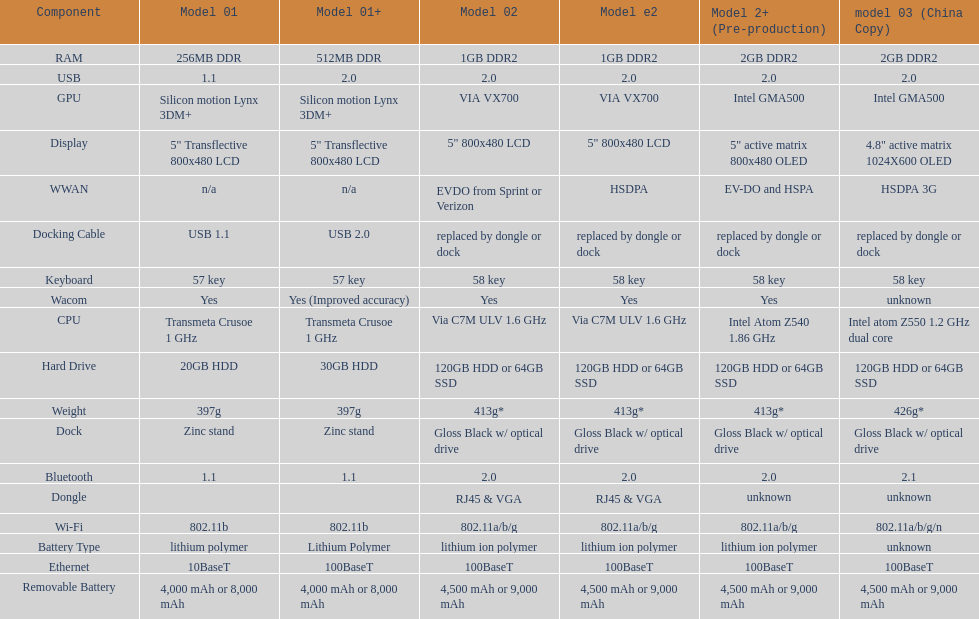Write the full table. {'header': ['Component', 'Model 01', 'Model 01+', 'Model 02', 'Model e2', 'Model 2+ (Pre-production)', 'model 03 (China Copy)'], 'rows': [['RAM', '256MB DDR', '512MB DDR', '1GB DDR2', '1GB DDR2', '2GB DDR2', '2GB DDR2'], ['USB', '1.1', '2.0', '2.0', '2.0', '2.0', '2.0'], ['GPU', 'Silicon motion Lynx 3DM+', 'Silicon motion Lynx 3DM+', 'VIA VX700', 'VIA VX700', 'Intel GMA500', 'Intel GMA500'], ['Display', '5" Transflective 800x480 LCD', '5" Transflective 800x480 LCD', '5" 800x480 LCD', '5" 800x480 LCD', '5" active matrix 800x480 OLED', '4.8" active matrix 1024X600 OLED'], ['WWAN', 'n/a', 'n/a', 'EVDO from Sprint or Verizon', 'HSDPA', 'EV-DO and HSPA', 'HSDPA 3G'], ['Docking Cable', 'USB 1.1', 'USB 2.0', 'replaced by dongle or dock', 'replaced by dongle or dock', 'replaced by dongle or dock', 'replaced by dongle or dock'], ['Keyboard', '57 key', '57 key', '58 key', '58 key', '58 key', '58 key'], ['Wacom', 'Yes', 'Yes (Improved accuracy)', 'Yes', 'Yes', 'Yes', 'unknown'], ['CPU', 'Transmeta Crusoe 1\xa0GHz', 'Transmeta Crusoe 1\xa0GHz', 'Via C7M ULV 1.6\xa0GHz', 'Via C7M ULV 1.6\xa0GHz', 'Intel Atom Z540 1.86\xa0GHz', 'Intel atom Z550 1.2\xa0GHz dual core'], ['Hard Drive', '20GB HDD', '30GB HDD', '120GB HDD or 64GB SSD', '120GB HDD or 64GB SSD', '120GB HDD or 64GB SSD', '120GB HDD or 64GB SSD'], ['Weight', '397g', '397g', '413g*', '413g*', '413g*', '426g*'], ['Dock', 'Zinc stand', 'Zinc stand', 'Gloss Black w/ optical drive', 'Gloss Black w/ optical drive', 'Gloss Black w/ optical drive', 'Gloss Black w/ optical drive'], ['Bluetooth', '1.1', '1.1', '2.0', '2.0', '2.0', '2.1'], ['Dongle', '', '', 'RJ45 & VGA', 'RJ45 & VGA', 'unknown', 'unknown'], ['Wi-Fi', '802.11b', '802.11b', '802.11a/b/g', '802.11a/b/g', '802.11a/b/g', '802.11a/b/g/n'], ['Battery Type', 'lithium polymer', 'Lithium Polymer', 'lithium ion polymer', 'lithium ion polymer', 'lithium ion polymer', 'unknown'], ['Ethernet', '10BaseT', '100BaseT', '100BaseT', '100BaseT', '100BaseT', '100BaseT'], ['Removable Battery', '4,000 mAh or 8,000 mAh', '4,000 mAh or 8,000 mAh', '4,500 mAh or 9,000 mAh', '4,500 mAh or 9,000 mAh', '4,500 mAh or 9,000 mAh', '4,500 mAh or 9,000 mAh']]} What is the next highest hard drive available after the 30gb model? 64GB SSD. 